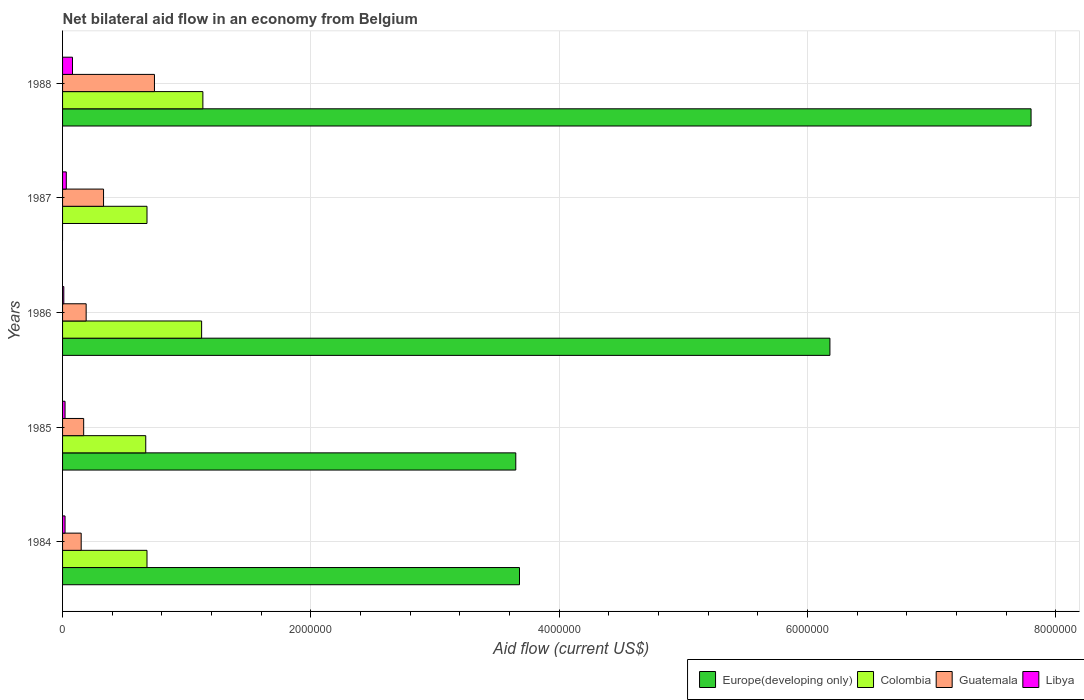Across all years, what is the minimum net bilateral aid flow in Colombia?
Provide a short and direct response. 6.70e+05. What is the total net bilateral aid flow in Colombia in the graph?
Give a very brief answer. 4.28e+06. What is the difference between the net bilateral aid flow in Europe(developing only) in 1984 and that in 1985?
Offer a terse response. 3.00e+04. What is the average net bilateral aid flow in Colombia per year?
Offer a terse response. 8.56e+05. In the year 1985, what is the difference between the net bilateral aid flow in Guatemala and net bilateral aid flow in Colombia?
Keep it short and to the point. -5.00e+05. In how many years, is the net bilateral aid flow in Europe(developing only) greater than 5600000 US$?
Offer a terse response. 2. What is the ratio of the net bilateral aid flow in Libya in 1986 to that in 1988?
Give a very brief answer. 0.12. What is the difference between the highest and the second highest net bilateral aid flow in Europe(developing only)?
Your answer should be compact. 1.62e+06. What is the difference between the highest and the lowest net bilateral aid flow in Europe(developing only)?
Your response must be concise. 7.80e+06. Is the sum of the net bilateral aid flow in Colombia in 1986 and 1988 greater than the maximum net bilateral aid flow in Libya across all years?
Provide a succinct answer. Yes. Is it the case that in every year, the sum of the net bilateral aid flow in Colombia and net bilateral aid flow in Guatemala is greater than the sum of net bilateral aid flow in Europe(developing only) and net bilateral aid flow in Libya?
Your answer should be compact. No. Is it the case that in every year, the sum of the net bilateral aid flow in Colombia and net bilateral aid flow in Europe(developing only) is greater than the net bilateral aid flow in Guatemala?
Offer a terse response. Yes. How many years are there in the graph?
Offer a terse response. 5. What is the difference between two consecutive major ticks on the X-axis?
Provide a succinct answer. 2.00e+06. Does the graph contain grids?
Provide a short and direct response. Yes. How are the legend labels stacked?
Ensure brevity in your answer.  Horizontal. What is the title of the graph?
Offer a terse response. Net bilateral aid flow in an economy from Belgium. Does "France" appear as one of the legend labels in the graph?
Provide a short and direct response. No. What is the label or title of the Y-axis?
Keep it short and to the point. Years. What is the Aid flow (current US$) in Europe(developing only) in 1984?
Give a very brief answer. 3.68e+06. What is the Aid flow (current US$) in Colombia in 1984?
Your answer should be compact. 6.80e+05. What is the Aid flow (current US$) in Guatemala in 1984?
Give a very brief answer. 1.50e+05. What is the Aid flow (current US$) of Europe(developing only) in 1985?
Offer a terse response. 3.65e+06. What is the Aid flow (current US$) in Colombia in 1985?
Ensure brevity in your answer.  6.70e+05. What is the Aid flow (current US$) in Europe(developing only) in 1986?
Your answer should be compact. 6.18e+06. What is the Aid flow (current US$) of Colombia in 1986?
Give a very brief answer. 1.12e+06. What is the Aid flow (current US$) in Guatemala in 1986?
Your answer should be compact. 1.90e+05. What is the Aid flow (current US$) in Europe(developing only) in 1987?
Offer a very short reply. 0. What is the Aid flow (current US$) in Colombia in 1987?
Provide a succinct answer. 6.80e+05. What is the Aid flow (current US$) in Guatemala in 1987?
Keep it short and to the point. 3.30e+05. What is the Aid flow (current US$) of Europe(developing only) in 1988?
Your answer should be very brief. 7.80e+06. What is the Aid flow (current US$) in Colombia in 1988?
Offer a terse response. 1.13e+06. What is the Aid flow (current US$) of Guatemala in 1988?
Make the answer very short. 7.40e+05. What is the Aid flow (current US$) of Libya in 1988?
Ensure brevity in your answer.  8.00e+04. Across all years, what is the maximum Aid flow (current US$) in Europe(developing only)?
Give a very brief answer. 7.80e+06. Across all years, what is the maximum Aid flow (current US$) of Colombia?
Provide a succinct answer. 1.13e+06. Across all years, what is the maximum Aid flow (current US$) in Guatemala?
Provide a short and direct response. 7.40e+05. Across all years, what is the minimum Aid flow (current US$) of Europe(developing only)?
Give a very brief answer. 0. Across all years, what is the minimum Aid flow (current US$) in Colombia?
Make the answer very short. 6.70e+05. Across all years, what is the minimum Aid flow (current US$) in Libya?
Ensure brevity in your answer.  10000. What is the total Aid flow (current US$) of Europe(developing only) in the graph?
Provide a succinct answer. 2.13e+07. What is the total Aid flow (current US$) in Colombia in the graph?
Keep it short and to the point. 4.28e+06. What is the total Aid flow (current US$) of Guatemala in the graph?
Offer a very short reply. 1.58e+06. What is the total Aid flow (current US$) of Libya in the graph?
Your answer should be compact. 1.60e+05. What is the difference between the Aid flow (current US$) of Europe(developing only) in 1984 and that in 1985?
Provide a succinct answer. 3.00e+04. What is the difference between the Aid flow (current US$) in Colombia in 1984 and that in 1985?
Your answer should be very brief. 10000. What is the difference between the Aid flow (current US$) in Libya in 1984 and that in 1985?
Offer a very short reply. 0. What is the difference between the Aid flow (current US$) in Europe(developing only) in 1984 and that in 1986?
Your response must be concise. -2.50e+06. What is the difference between the Aid flow (current US$) in Colombia in 1984 and that in 1986?
Your answer should be very brief. -4.40e+05. What is the difference between the Aid flow (current US$) of Colombia in 1984 and that in 1987?
Provide a succinct answer. 0. What is the difference between the Aid flow (current US$) in Libya in 1984 and that in 1987?
Offer a terse response. -10000. What is the difference between the Aid flow (current US$) in Europe(developing only) in 1984 and that in 1988?
Your answer should be very brief. -4.12e+06. What is the difference between the Aid flow (current US$) in Colombia in 1984 and that in 1988?
Make the answer very short. -4.50e+05. What is the difference between the Aid flow (current US$) in Guatemala in 1984 and that in 1988?
Make the answer very short. -5.90e+05. What is the difference between the Aid flow (current US$) of Europe(developing only) in 1985 and that in 1986?
Give a very brief answer. -2.53e+06. What is the difference between the Aid flow (current US$) in Colombia in 1985 and that in 1986?
Provide a short and direct response. -4.50e+05. What is the difference between the Aid flow (current US$) of Colombia in 1985 and that in 1987?
Keep it short and to the point. -10000. What is the difference between the Aid flow (current US$) in Guatemala in 1985 and that in 1987?
Your response must be concise. -1.60e+05. What is the difference between the Aid flow (current US$) in Libya in 1985 and that in 1987?
Offer a terse response. -10000. What is the difference between the Aid flow (current US$) in Europe(developing only) in 1985 and that in 1988?
Provide a succinct answer. -4.15e+06. What is the difference between the Aid flow (current US$) in Colombia in 1985 and that in 1988?
Provide a short and direct response. -4.60e+05. What is the difference between the Aid flow (current US$) of Guatemala in 1985 and that in 1988?
Your answer should be compact. -5.70e+05. What is the difference between the Aid flow (current US$) of Colombia in 1986 and that in 1987?
Give a very brief answer. 4.40e+05. What is the difference between the Aid flow (current US$) in Guatemala in 1986 and that in 1987?
Provide a succinct answer. -1.40e+05. What is the difference between the Aid flow (current US$) of Libya in 1986 and that in 1987?
Ensure brevity in your answer.  -2.00e+04. What is the difference between the Aid flow (current US$) in Europe(developing only) in 1986 and that in 1988?
Your response must be concise. -1.62e+06. What is the difference between the Aid flow (current US$) of Guatemala in 1986 and that in 1988?
Offer a terse response. -5.50e+05. What is the difference between the Aid flow (current US$) in Libya in 1986 and that in 1988?
Ensure brevity in your answer.  -7.00e+04. What is the difference between the Aid flow (current US$) of Colombia in 1987 and that in 1988?
Provide a short and direct response. -4.50e+05. What is the difference between the Aid flow (current US$) in Guatemala in 1987 and that in 1988?
Provide a short and direct response. -4.10e+05. What is the difference between the Aid flow (current US$) of Libya in 1987 and that in 1988?
Provide a succinct answer. -5.00e+04. What is the difference between the Aid flow (current US$) of Europe(developing only) in 1984 and the Aid flow (current US$) of Colombia in 1985?
Ensure brevity in your answer.  3.01e+06. What is the difference between the Aid flow (current US$) in Europe(developing only) in 1984 and the Aid flow (current US$) in Guatemala in 1985?
Your answer should be very brief. 3.51e+06. What is the difference between the Aid flow (current US$) in Europe(developing only) in 1984 and the Aid flow (current US$) in Libya in 1985?
Your response must be concise. 3.66e+06. What is the difference between the Aid flow (current US$) in Colombia in 1984 and the Aid flow (current US$) in Guatemala in 1985?
Provide a short and direct response. 5.10e+05. What is the difference between the Aid flow (current US$) in Colombia in 1984 and the Aid flow (current US$) in Libya in 1985?
Keep it short and to the point. 6.60e+05. What is the difference between the Aid flow (current US$) in Europe(developing only) in 1984 and the Aid flow (current US$) in Colombia in 1986?
Make the answer very short. 2.56e+06. What is the difference between the Aid flow (current US$) in Europe(developing only) in 1984 and the Aid flow (current US$) in Guatemala in 1986?
Your response must be concise. 3.49e+06. What is the difference between the Aid flow (current US$) of Europe(developing only) in 1984 and the Aid flow (current US$) of Libya in 1986?
Provide a short and direct response. 3.67e+06. What is the difference between the Aid flow (current US$) of Colombia in 1984 and the Aid flow (current US$) of Guatemala in 1986?
Provide a short and direct response. 4.90e+05. What is the difference between the Aid flow (current US$) in Colombia in 1984 and the Aid flow (current US$) in Libya in 1986?
Give a very brief answer. 6.70e+05. What is the difference between the Aid flow (current US$) in Europe(developing only) in 1984 and the Aid flow (current US$) in Guatemala in 1987?
Offer a terse response. 3.35e+06. What is the difference between the Aid flow (current US$) of Europe(developing only) in 1984 and the Aid flow (current US$) of Libya in 1987?
Provide a succinct answer. 3.65e+06. What is the difference between the Aid flow (current US$) in Colombia in 1984 and the Aid flow (current US$) in Libya in 1987?
Make the answer very short. 6.50e+05. What is the difference between the Aid flow (current US$) in Guatemala in 1984 and the Aid flow (current US$) in Libya in 1987?
Make the answer very short. 1.20e+05. What is the difference between the Aid flow (current US$) in Europe(developing only) in 1984 and the Aid flow (current US$) in Colombia in 1988?
Keep it short and to the point. 2.55e+06. What is the difference between the Aid flow (current US$) of Europe(developing only) in 1984 and the Aid flow (current US$) of Guatemala in 1988?
Give a very brief answer. 2.94e+06. What is the difference between the Aid flow (current US$) of Europe(developing only) in 1984 and the Aid flow (current US$) of Libya in 1988?
Keep it short and to the point. 3.60e+06. What is the difference between the Aid flow (current US$) in Colombia in 1984 and the Aid flow (current US$) in Libya in 1988?
Provide a succinct answer. 6.00e+05. What is the difference between the Aid flow (current US$) of Guatemala in 1984 and the Aid flow (current US$) of Libya in 1988?
Your answer should be compact. 7.00e+04. What is the difference between the Aid flow (current US$) of Europe(developing only) in 1985 and the Aid flow (current US$) of Colombia in 1986?
Your answer should be compact. 2.53e+06. What is the difference between the Aid flow (current US$) in Europe(developing only) in 1985 and the Aid flow (current US$) in Guatemala in 1986?
Offer a very short reply. 3.46e+06. What is the difference between the Aid flow (current US$) in Europe(developing only) in 1985 and the Aid flow (current US$) in Libya in 1986?
Your response must be concise. 3.64e+06. What is the difference between the Aid flow (current US$) in Colombia in 1985 and the Aid flow (current US$) in Libya in 1986?
Offer a very short reply. 6.60e+05. What is the difference between the Aid flow (current US$) in Guatemala in 1985 and the Aid flow (current US$) in Libya in 1986?
Your answer should be compact. 1.60e+05. What is the difference between the Aid flow (current US$) in Europe(developing only) in 1985 and the Aid flow (current US$) in Colombia in 1987?
Your answer should be very brief. 2.97e+06. What is the difference between the Aid flow (current US$) of Europe(developing only) in 1985 and the Aid flow (current US$) of Guatemala in 1987?
Provide a short and direct response. 3.32e+06. What is the difference between the Aid flow (current US$) of Europe(developing only) in 1985 and the Aid flow (current US$) of Libya in 1987?
Provide a short and direct response. 3.62e+06. What is the difference between the Aid flow (current US$) of Colombia in 1985 and the Aid flow (current US$) of Libya in 1987?
Your answer should be compact. 6.40e+05. What is the difference between the Aid flow (current US$) in Guatemala in 1985 and the Aid flow (current US$) in Libya in 1987?
Give a very brief answer. 1.40e+05. What is the difference between the Aid flow (current US$) in Europe(developing only) in 1985 and the Aid flow (current US$) in Colombia in 1988?
Your response must be concise. 2.52e+06. What is the difference between the Aid flow (current US$) of Europe(developing only) in 1985 and the Aid flow (current US$) of Guatemala in 1988?
Offer a very short reply. 2.91e+06. What is the difference between the Aid flow (current US$) of Europe(developing only) in 1985 and the Aid flow (current US$) of Libya in 1988?
Your answer should be compact. 3.57e+06. What is the difference between the Aid flow (current US$) in Colombia in 1985 and the Aid flow (current US$) in Libya in 1988?
Offer a very short reply. 5.90e+05. What is the difference between the Aid flow (current US$) in Europe(developing only) in 1986 and the Aid flow (current US$) in Colombia in 1987?
Ensure brevity in your answer.  5.50e+06. What is the difference between the Aid flow (current US$) in Europe(developing only) in 1986 and the Aid flow (current US$) in Guatemala in 1987?
Give a very brief answer. 5.85e+06. What is the difference between the Aid flow (current US$) of Europe(developing only) in 1986 and the Aid flow (current US$) of Libya in 1987?
Make the answer very short. 6.15e+06. What is the difference between the Aid flow (current US$) of Colombia in 1986 and the Aid flow (current US$) of Guatemala in 1987?
Provide a short and direct response. 7.90e+05. What is the difference between the Aid flow (current US$) in Colombia in 1986 and the Aid flow (current US$) in Libya in 1987?
Provide a short and direct response. 1.09e+06. What is the difference between the Aid flow (current US$) of Europe(developing only) in 1986 and the Aid flow (current US$) of Colombia in 1988?
Your answer should be very brief. 5.05e+06. What is the difference between the Aid flow (current US$) of Europe(developing only) in 1986 and the Aid flow (current US$) of Guatemala in 1988?
Your answer should be very brief. 5.44e+06. What is the difference between the Aid flow (current US$) of Europe(developing only) in 1986 and the Aid flow (current US$) of Libya in 1988?
Give a very brief answer. 6.10e+06. What is the difference between the Aid flow (current US$) of Colombia in 1986 and the Aid flow (current US$) of Libya in 1988?
Your response must be concise. 1.04e+06. What is the difference between the Aid flow (current US$) of Guatemala in 1986 and the Aid flow (current US$) of Libya in 1988?
Your answer should be compact. 1.10e+05. What is the difference between the Aid flow (current US$) of Colombia in 1987 and the Aid flow (current US$) of Guatemala in 1988?
Provide a short and direct response. -6.00e+04. What is the average Aid flow (current US$) in Europe(developing only) per year?
Offer a terse response. 4.26e+06. What is the average Aid flow (current US$) in Colombia per year?
Keep it short and to the point. 8.56e+05. What is the average Aid flow (current US$) in Guatemala per year?
Your answer should be very brief. 3.16e+05. What is the average Aid flow (current US$) of Libya per year?
Offer a very short reply. 3.20e+04. In the year 1984, what is the difference between the Aid flow (current US$) in Europe(developing only) and Aid flow (current US$) in Colombia?
Make the answer very short. 3.00e+06. In the year 1984, what is the difference between the Aid flow (current US$) of Europe(developing only) and Aid flow (current US$) of Guatemala?
Provide a succinct answer. 3.53e+06. In the year 1984, what is the difference between the Aid flow (current US$) of Europe(developing only) and Aid flow (current US$) of Libya?
Your answer should be compact. 3.66e+06. In the year 1984, what is the difference between the Aid flow (current US$) in Colombia and Aid flow (current US$) in Guatemala?
Keep it short and to the point. 5.30e+05. In the year 1984, what is the difference between the Aid flow (current US$) of Guatemala and Aid flow (current US$) of Libya?
Offer a terse response. 1.30e+05. In the year 1985, what is the difference between the Aid flow (current US$) in Europe(developing only) and Aid flow (current US$) in Colombia?
Keep it short and to the point. 2.98e+06. In the year 1985, what is the difference between the Aid flow (current US$) in Europe(developing only) and Aid flow (current US$) in Guatemala?
Ensure brevity in your answer.  3.48e+06. In the year 1985, what is the difference between the Aid flow (current US$) of Europe(developing only) and Aid flow (current US$) of Libya?
Give a very brief answer. 3.63e+06. In the year 1985, what is the difference between the Aid flow (current US$) in Colombia and Aid flow (current US$) in Guatemala?
Offer a terse response. 5.00e+05. In the year 1985, what is the difference between the Aid flow (current US$) in Colombia and Aid flow (current US$) in Libya?
Offer a very short reply. 6.50e+05. In the year 1985, what is the difference between the Aid flow (current US$) in Guatemala and Aid flow (current US$) in Libya?
Make the answer very short. 1.50e+05. In the year 1986, what is the difference between the Aid flow (current US$) in Europe(developing only) and Aid flow (current US$) in Colombia?
Give a very brief answer. 5.06e+06. In the year 1986, what is the difference between the Aid flow (current US$) in Europe(developing only) and Aid flow (current US$) in Guatemala?
Make the answer very short. 5.99e+06. In the year 1986, what is the difference between the Aid flow (current US$) of Europe(developing only) and Aid flow (current US$) of Libya?
Provide a short and direct response. 6.17e+06. In the year 1986, what is the difference between the Aid flow (current US$) in Colombia and Aid flow (current US$) in Guatemala?
Ensure brevity in your answer.  9.30e+05. In the year 1986, what is the difference between the Aid flow (current US$) in Colombia and Aid flow (current US$) in Libya?
Your answer should be very brief. 1.11e+06. In the year 1986, what is the difference between the Aid flow (current US$) of Guatemala and Aid flow (current US$) of Libya?
Provide a succinct answer. 1.80e+05. In the year 1987, what is the difference between the Aid flow (current US$) in Colombia and Aid flow (current US$) in Guatemala?
Give a very brief answer. 3.50e+05. In the year 1987, what is the difference between the Aid flow (current US$) in Colombia and Aid flow (current US$) in Libya?
Make the answer very short. 6.50e+05. In the year 1987, what is the difference between the Aid flow (current US$) in Guatemala and Aid flow (current US$) in Libya?
Your response must be concise. 3.00e+05. In the year 1988, what is the difference between the Aid flow (current US$) in Europe(developing only) and Aid flow (current US$) in Colombia?
Provide a succinct answer. 6.67e+06. In the year 1988, what is the difference between the Aid flow (current US$) of Europe(developing only) and Aid flow (current US$) of Guatemala?
Give a very brief answer. 7.06e+06. In the year 1988, what is the difference between the Aid flow (current US$) in Europe(developing only) and Aid flow (current US$) in Libya?
Give a very brief answer. 7.72e+06. In the year 1988, what is the difference between the Aid flow (current US$) of Colombia and Aid flow (current US$) of Libya?
Your answer should be compact. 1.05e+06. In the year 1988, what is the difference between the Aid flow (current US$) in Guatemala and Aid flow (current US$) in Libya?
Your answer should be compact. 6.60e+05. What is the ratio of the Aid flow (current US$) of Europe(developing only) in 1984 to that in 1985?
Your answer should be very brief. 1.01. What is the ratio of the Aid flow (current US$) of Colombia in 1984 to that in 1985?
Provide a short and direct response. 1.01. What is the ratio of the Aid flow (current US$) of Guatemala in 1984 to that in 1985?
Your answer should be compact. 0.88. What is the ratio of the Aid flow (current US$) of Libya in 1984 to that in 1985?
Keep it short and to the point. 1. What is the ratio of the Aid flow (current US$) of Europe(developing only) in 1984 to that in 1986?
Your response must be concise. 0.6. What is the ratio of the Aid flow (current US$) of Colombia in 1984 to that in 1986?
Provide a short and direct response. 0.61. What is the ratio of the Aid flow (current US$) of Guatemala in 1984 to that in 1986?
Offer a very short reply. 0.79. What is the ratio of the Aid flow (current US$) in Guatemala in 1984 to that in 1987?
Provide a short and direct response. 0.45. What is the ratio of the Aid flow (current US$) of Europe(developing only) in 1984 to that in 1988?
Your answer should be compact. 0.47. What is the ratio of the Aid flow (current US$) in Colombia in 1984 to that in 1988?
Provide a short and direct response. 0.6. What is the ratio of the Aid flow (current US$) in Guatemala in 1984 to that in 1988?
Make the answer very short. 0.2. What is the ratio of the Aid flow (current US$) in Libya in 1984 to that in 1988?
Offer a very short reply. 0.25. What is the ratio of the Aid flow (current US$) in Europe(developing only) in 1985 to that in 1986?
Offer a very short reply. 0.59. What is the ratio of the Aid flow (current US$) in Colombia in 1985 to that in 1986?
Make the answer very short. 0.6. What is the ratio of the Aid flow (current US$) in Guatemala in 1985 to that in 1986?
Your answer should be compact. 0.89. What is the ratio of the Aid flow (current US$) of Libya in 1985 to that in 1986?
Your answer should be very brief. 2. What is the ratio of the Aid flow (current US$) in Guatemala in 1985 to that in 1987?
Keep it short and to the point. 0.52. What is the ratio of the Aid flow (current US$) of Europe(developing only) in 1985 to that in 1988?
Offer a very short reply. 0.47. What is the ratio of the Aid flow (current US$) of Colombia in 1985 to that in 1988?
Your answer should be very brief. 0.59. What is the ratio of the Aid flow (current US$) of Guatemala in 1985 to that in 1988?
Offer a very short reply. 0.23. What is the ratio of the Aid flow (current US$) of Libya in 1985 to that in 1988?
Offer a very short reply. 0.25. What is the ratio of the Aid flow (current US$) in Colombia in 1986 to that in 1987?
Make the answer very short. 1.65. What is the ratio of the Aid flow (current US$) of Guatemala in 1986 to that in 1987?
Provide a short and direct response. 0.58. What is the ratio of the Aid flow (current US$) in Libya in 1986 to that in 1987?
Give a very brief answer. 0.33. What is the ratio of the Aid flow (current US$) of Europe(developing only) in 1986 to that in 1988?
Make the answer very short. 0.79. What is the ratio of the Aid flow (current US$) in Guatemala in 1986 to that in 1988?
Your answer should be compact. 0.26. What is the ratio of the Aid flow (current US$) of Colombia in 1987 to that in 1988?
Your answer should be very brief. 0.6. What is the ratio of the Aid flow (current US$) in Guatemala in 1987 to that in 1988?
Offer a very short reply. 0.45. What is the difference between the highest and the second highest Aid flow (current US$) of Europe(developing only)?
Ensure brevity in your answer.  1.62e+06. What is the difference between the highest and the second highest Aid flow (current US$) of Colombia?
Your answer should be compact. 10000. What is the difference between the highest and the second highest Aid flow (current US$) of Guatemala?
Provide a short and direct response. 4.10e+05. What is the difference between the highest and the lowest Aid flow (current US$) in Europe(developing only)?
Your response must be concise. 7.80e+06. What is the difference between the highest and the lowest Aid flow (current US$) in Guatemala?
Give a very brief answer. 5.90e+05. 